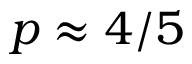<formula> <loc_0><loc_0><loc_500><loc_500>p \approx 4 / 5</formula> 